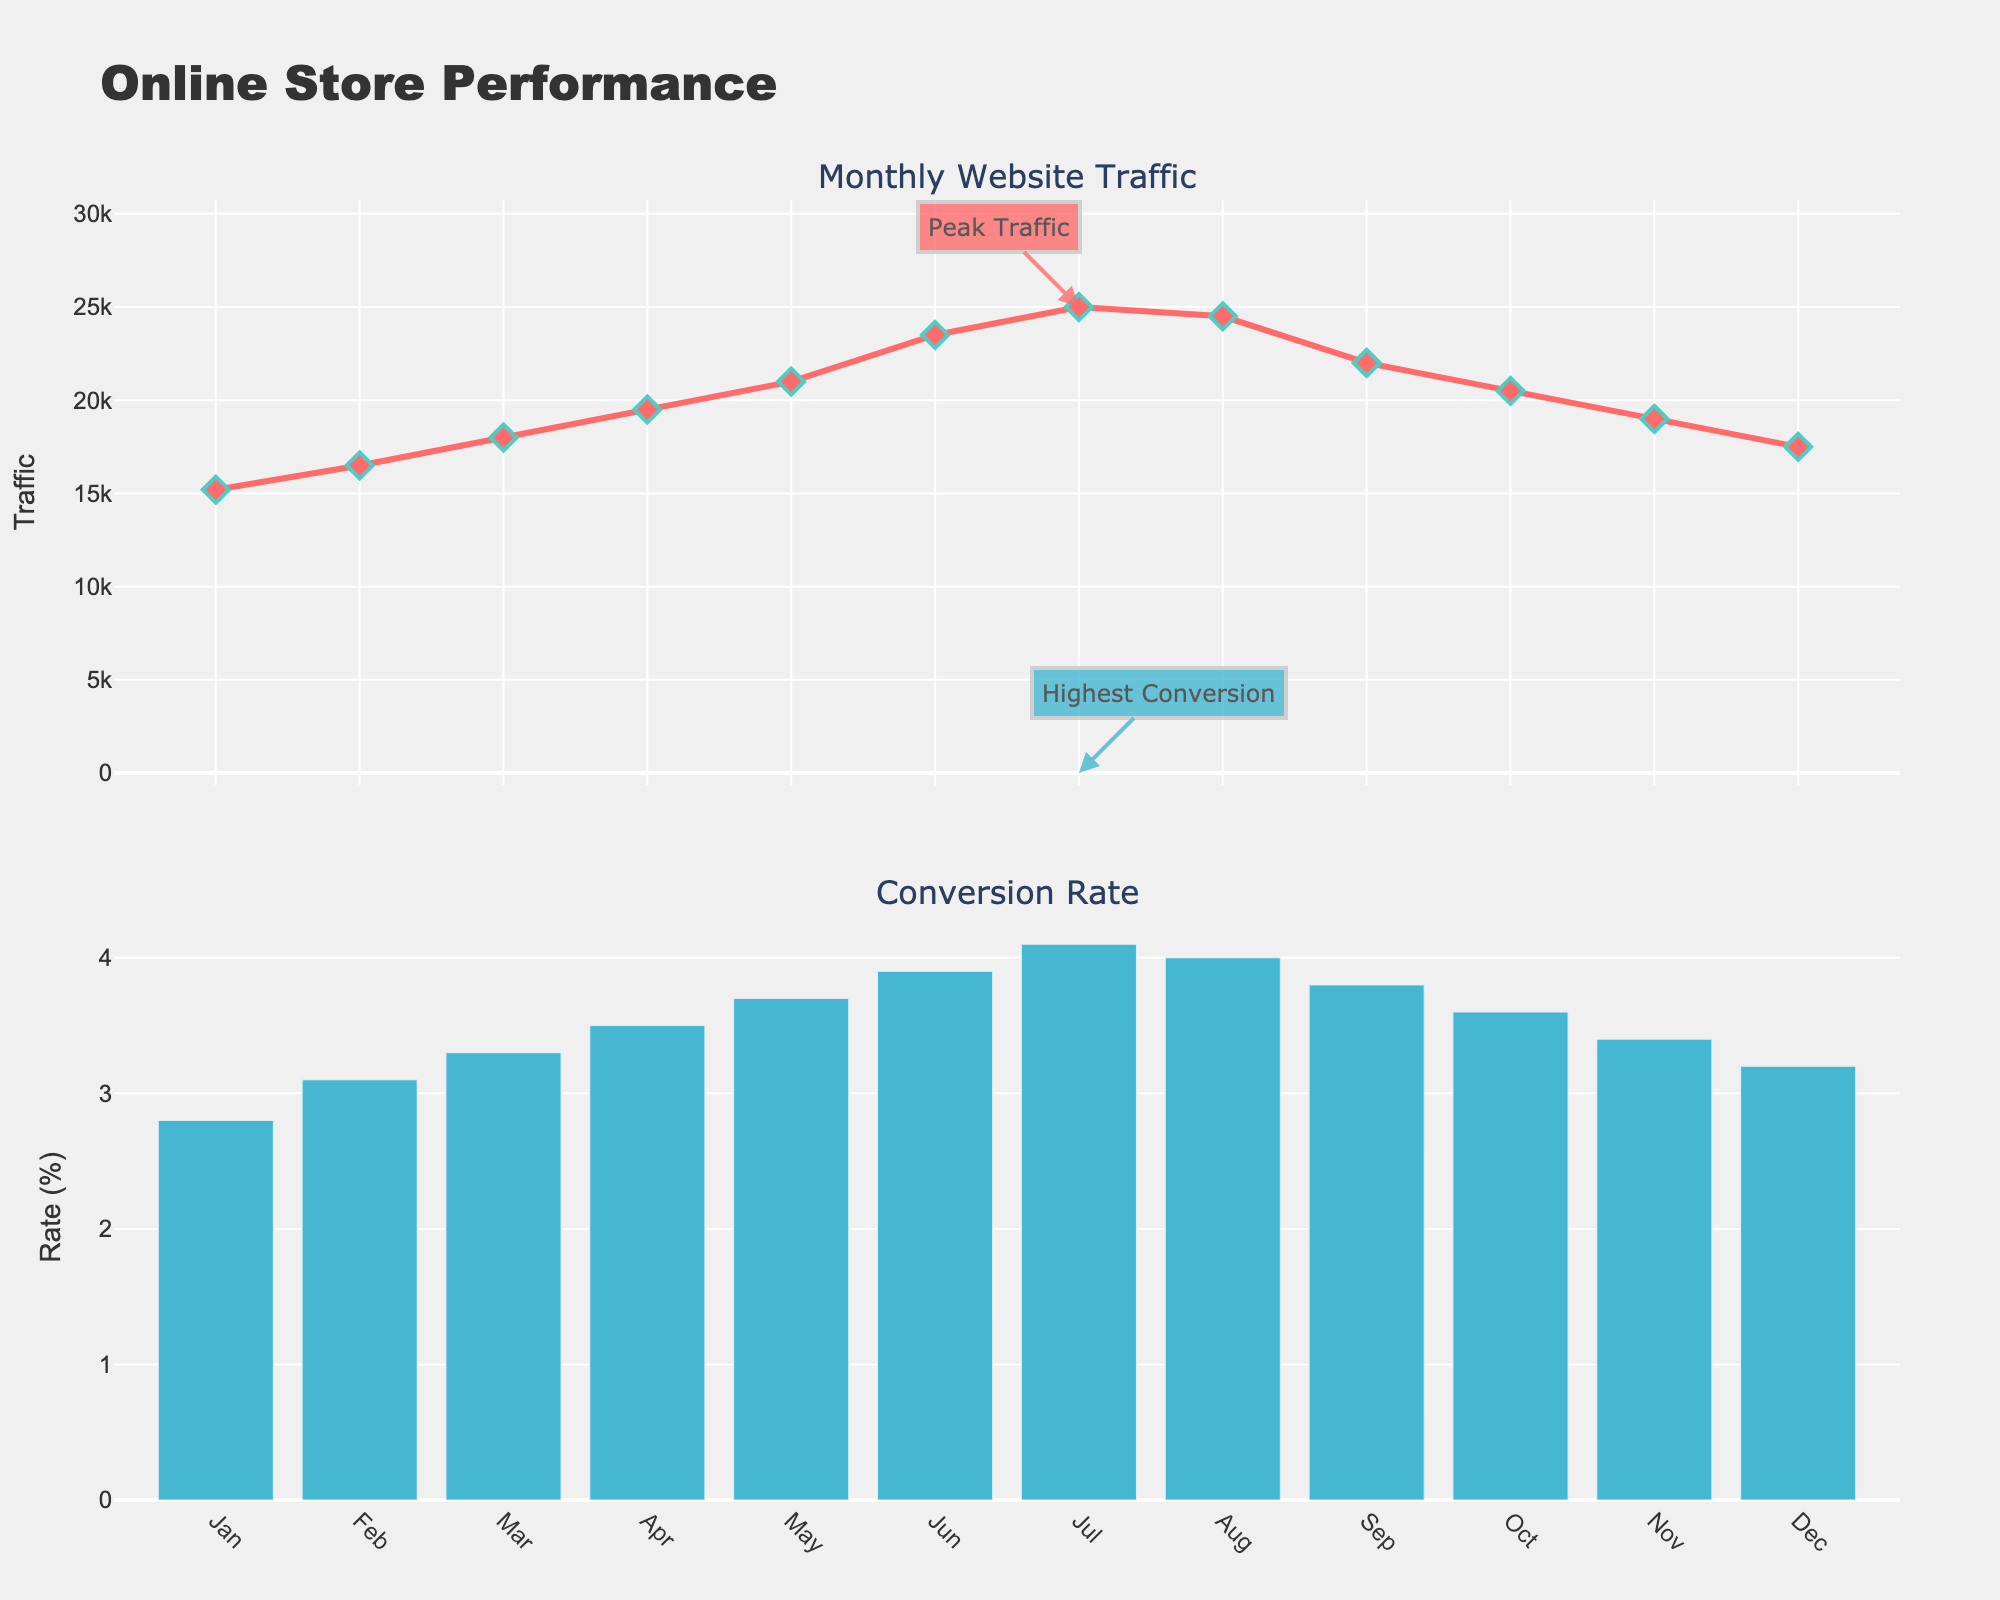What's the title on the plot? The title on the plot is clearly marked at the top. It reads "Online Store Performance".
Answer: Online Store Performance What month had the highest website traffic and what was the value? By analyzing the first subplot (line plot for Monthly Website Traffic), the highest point can be seen in July with a traffic value of 25,000.
Answer: July, 25,000 How does the website traffic change from January to July? The website traffic starts at 15,200 in January and increases to 25,000 in July. The trend in the line plot shows a consistent increase each month.
Answer: Increases consistently What is the conversion rate for December? By examining the bar plot (Conversion Rate) for December, you can see the height of the bar corresponds to a conversion rate value of 3.2%.
Answer: 3.2% Which month has the lowest conversion rate and what is the value? Looking at the bar plot for Conversion Rate, the shortest bar is in January, indicating the lowest conversion rate of 2.8%.
Answer: January, 2.8% Compare the conversion rates of February and October. By comparing the bars corresponding to February and October in the Conversion Rate subplot, February has a rate of 3.1% and October has a rate of 3.6%.
Answer: October > February What is the average conversion rate for the first quarter of the year? To calculate the average, add the conversion rates for January, February, and March (2.8 + 3.1 + 3.3) and divide by the number of months (3). (2.8 + 3.1 + 3.3) / 3 = 3.07%.
Answer: 3.07% By how much did the website traffic decrease from August to September? The website traffic in August was 24,500 and in September it was 22,000. The difference is 24,500 - 22,000.
Answer: 2,500 What trend can you observe about the website traffic in the fourth quarter? By examining the line plot for October, November, and December, the traffic decreases from 20,500 to 19,000 and then to 17,500. The trend is a decline.
Answer: Declining trend What insight can you derive from the annotations in July? The annotations on the plot highlight that July had both the peak website traffic (25,000) and the highest conversion rate (4.1%).
Answer: Both highest traffic and conversion rate in July 